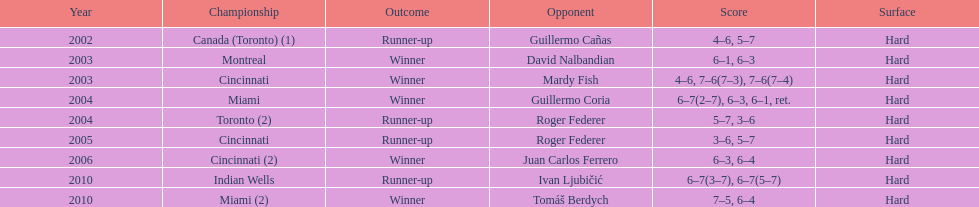What was the highest number of consecutive wins? 3. 